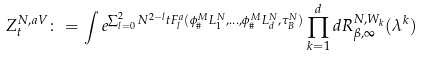Convert formula to latex. <formula><loc_0><loc_0><loc_500><loc_500>Z ^ { N , a V } _ { t } \colon = \int e ^ { \sum _ { l = 0 } ^ { 2 } N ^ { 2 - l } t F _ { l } ^ { a } ( \phi ^ { M } _ { \# } L ^ { N } _ { 1 } , \dots , \phi ^ { M } _ { \# } L ^ { N } _ { d } , \tau _ { B } ^ { N } ) } \prod _ { k = 1 } ^ { d } d R ^ { N , W _ { k } } _ { \beta , \infty } ( \lambda ^ { k } )</formula> 